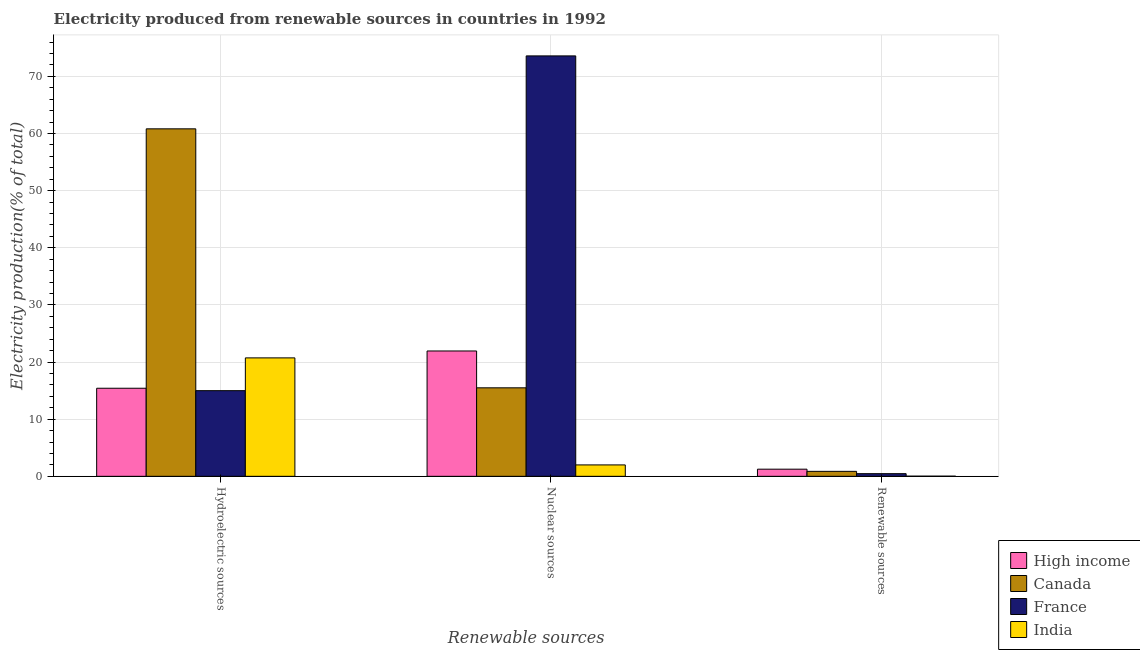How many groups of bars are there?
Make the answer very short. 3. Are the number of bars on each tick of the X-axis equal?
Keep it short and to the point. Yes. What is the label of the 3rd group of bars from the left?
Offer a terse response. Renewable sources. What is the percentage of electricity produced by nuclear sources in High income?
Your response must be concise. 21.93. Across all countries, what is the maximum percentage of electricity produced by renewable sources?
Keep it short and to the point. 1.25. Across all countries, what is the minimum percentage of electricity produced by renewable sources?
Offer a very short reply. 0.03. In which country was the percentage of electricity produced by renewable sources maximum?
Your answer should be compact. High income. What is the total percentage of electricity produced by renewable sources in the graph?
Ensure brevity in your answer.  2.61. What is the difference between the percentage of electricity produced by hydroelectric sources in High income and that in Canada?
Give a very brief answer. -45.4. What is the difference between the percentage of electricity produced by nuclear sources in India and the percentage of electricity produced by renewable sources in Canada?
Keep it short and to the point. 1.12. What is the average percentage of electricity produced by nuclear sources per country?
Provide a succinct answer. 28.25. What is the difference between the percentage of electricity produced by nuclear sources and percentage of electricity produced by hydroelectric sources in Canada?
Provide a short and direct response. -45.32. What is the ratio of the percentage of electricity produced by renewable sources in France to that in High income?
Keep it short and to the point. 0.37. What is the difference between the highest and the second highest percentage of electricity produced by renewable sources?
Keep it short and to the point. 0.38. What is the difference between the highest and the lowest percentage of electricity produced by hydroelectric sources?
Offer a terse response. 45.82. In how many countries, is the percentage of electricity produced by nuclear sources greater than the average percentage of electricity produced by nuclear sources taken over all countries?
Keep it short and to the point. 1. What does the 1st bar from the left in Renewable sources represents?
Offer a very short reply. High income. What does the 3rd bar from the right in Nuclear sources represents?
Your response must be concise. Canada. How many bars are there?
Your answer should be very brief. 12. How many countries are there in the graph?
Offer a terse response. 4. How many legend labels are there?
Provide a succinct answer. 4. What is the title of the graph?
Your answer should be very brief. Electricity produced from renewable sources in countries in 1992. Does "Grenada" appear as one of the legend labels in the graph?
Your response must be concise. No. What is the label or title of the X-axis?
Give a very brief answer. Renewable sources. What is the Electricity production(% of total) in High income in Hydroelectric sources?
Ensure brevity in your answer.  15.41. What is the Electricity production(% of total) in Canada in Hydroelectric sources?
Offer a very short reply. 60.81. What is the Electricity production(% of total) in France in Hydroelectric sources?
Make the answer very short. 14.99. What is the Electricity production(% of total) of India in Hydroelectric sources?
Provide a succinct answer. 20.73. What is the Electricity production(% of total) of High income in Nuclear sources?
Keep it short and to the point. 21.93. What is the Electricity production(% of total) of Canada in Nuclear sources?
Offer a very short reply. 15.49. What is the Electricity production(% of total) of France in Nuclear sources?
Offer a very short reply. 73.57. What is the Electricity production(% of total) of India in Nuclear sources?
Your answer should be very brief. 1.99. What is the Electricity production(% of total) in High income in Renewable sources?
Your answer should be compact. 1.25. What is the Electricity production(% of total) in Canada in Renewable sources?
Keep it short and to the point. 0.87. What is the Electricity production(% of total) of France in Renewable sources?
Offer a terse response. 0.46. What is the Electricity production(% of total) in India in Renewable sources?
Provide a short and direct response. 0.03. Across all Renewable sources, what is the maximum Electricity production(% of total) of High income?
Offer a very short reply. 21.93. Across all Renewable sources, what is the maximum Electricity production(% of total) of Canada?
Keep it short and to the point. 60.81. Across all Renewable sources, what is the maximum Electricity production(% of total) in France?
Your answer should be compact. 73.57. Across all Renewable sources, what is the maximum Electricity production(% of total) of India?
Your response must be concise. 20.73. Across all Renewable sources, what is the minimum Electricity production(% of total) in High income?
Offer a very short reply. 1.25. Across all Renewable sources, what is the minimum Electricity production(% of total) in Canada?
Your answer should be compact. 0.87. Across all Renewable sources, what is the minimum Electricity production(% of total) of France?
Provide a succinct answer. 0.46. Across all Renewable sources, what is the minimum Electricity production(% of total) in India?
Make the answer very short. 0.03. What is the total Electricity production(% of total) in High income in the graph?
Offer a terse response. 38.6. What is the total Electricity production(% of total) in Canada in the graph?
Ensure brevity in your answer.  77.17. What is the total Electricity production(% of total) of France in the graph?
Your response must be concise. 89.03. What is the total Electricity production(% of total) in India in the graph?
Your answer should be compact. 22.75. What is the difference between the Electricity production(% of total) in High income in Hydroelectric sources and that in Nuclear sources?
Offer a very short reply. -6.52. What is the difference between the Electricity production(% of total) in Canada in Hydroelectric sources and that in Nuclear sources?
Provide a succinct answer. 45.32. What is the difference between the Electricity production(% of total) of France in Hydroelectric sources and that in Nuclear sources?
Provide a short and direct response. -58.58. What is the difference between the Electricity production(% of total) in India in Hydroelectric sources and that in Nuclear sources?
Keep it short and to the point. 18.73. What is the difference between the Electricity production(% of total) in High income in Hydroelectric sources and that in Renewable sources?
Provide a short and direct response. 14.16. What is the difference between the Electricity production(% of total) in Canada in Hydroelectric sources and that in Renewable sources?
Offer a very short reply. 59.94. What is the difference between the Electricity production(% of total) of France in Hydroelectric sources and that in Renewable sources?
Provide a succinct answer. 14.53. What is the difference between the Electricity production(% of total) in India in Hydroelectric sources and that in Renewable sources?
Make the answer very short. 20.7. What is the difference between the Electricity production(% of total) of High income in Nuclear sources and that in Renewable sources?
Offer a terse response. 20.68. What is the difference between the Electricity production(% of total) of Canada in Nuclear sources and that in Renewable sources?
Offer a very short reply. 14.62. What is the difference between the Electricity production(% of total) in France in Nuclear sources and that in Renewable sources?
Your response must be concise. 73.11. What is the difference between the Electricity production(% of total) in India in Nuclear sources and that in Renewable sources?
Your answer should be very brief. 1.97. What is the difference between the Electricity production(% of total) in High income in Hydroelectric sources and the Electricity production(% of total) in Canada in Nuclear sources?
Offer a terse response. -0.08. What is the difference between the Electricity production(% of total) of High income in Hydroelectric sources and the Electricity production(% of total) of France in Nuclear sources?
Give a very brief answer. -58.16. What is the difference between the Electricity production(% of total) of High income in Hydroelectric sources and the Electricity production(% of total) of India in Nuclear sources?
Ensure brevity in your answer.  13.42. What is the difference between the Electricity production(% of total) of Canada in Hydroelectric sources and the Electricity production(% of total) of France in Nuclear sources?
Make the answer very short. -12.76. What is the difference between the Electricity production(% of total) of Canada in Hydroelectric sources and the Electricity production(% of total) of India in Nuclear sources?
Offer a very short reply. 58.81. What is the difference between the Electricity production(% of total) of France in Hydroelectric sources and the Electricity production(% of total) of India in Nuclear sources?
Provide a short and direct response. 13. What is the difference between the Electricity production(% of total) of High income in Hydroelectric sources and the Electricity production(% of total) of Canada in Renewable sources?
Your response must be concise. 14.54. What is the difference between the Electricity production(% of total) of High income in Hydroelectric sources and the Electricity production(% of total) of France in Renewable sources?
Keep it short and to the point. 14.95. What is the difference between the Electricity production(% of total) in High income in Hydroelectric sources and the Electricity production(% of total) in India in Renewable sources?
Provide a short and direct response. 15.39. What is the difference between the Electricity production(% of total) of Canada in Hydroelectric sources and the Electricity production(% of total) of France in Renewable sources?
Provide a short and direct response. 60.35. What is the difference between the Electricity production(% of total) in Canada in Hydroelectric sources and the Electricity production(% of total) in India in Renewable sources?
Ensure brevity in your answer.  60.78. What is the difference between the Electricity production(% of total) in France in Hydroelectric sources and the Electricity production(% of total) in India in Renewable sources?
Make the answer very short. 14.96. What is the difference between the Electricity production(% of total) in High income in Nuclear sources and the Electricity production(% of total) in Canada in Renewable sources?
Your answer should be very brief. 21.06. What is the difference between the Electricity production(% of total) of High income in Nuclear sources and the Electricity production(% of total) of France in Renewable sources?
Keep it short and to the point. 21.47. What is the difference between the Electricity production(% of total) in High income in Nuclear sources and the Electricity production(% of total) in India in Renewable sources?
Offer a very short reply. 21.91. What is the difference between the Electricity production(% of total) of Canada in Nuclear sources and the Electricity production(% of total) of France in Renewable sources?
Give a very brief answer. 15.02. What is the difference between the Electricity production(% of total) in Canada in Nuclear sources and the Electricity production(% of total) in India in Renewable sources?
Your response must be concise. 15.46. What is the difference between the Electricity production(% of total) in France in Nuclear sources and the Electricity production(% of total) in India in Renewable sources?
Offer a terse response. 73.55. What is the average Electricity production(% of total) in High income per Renewable sources?
Give a very brief answer. 12.87. What is the average Electricity production(% of total) in Canada per Renewable sources?
Provide a succinct answer. 25.72. What is the average Electricity production(% of total) in France per Renewable sources?
Offer a terse response. 29.68. What is the average Electricity production(% of total) in India per Renewable sources?
Give a very brief answer. 7.58. What is the difference between the Electricity production(% of total) of High income and Electricity production(% of total) of Canada in Hydroelectric sources?
Keep it short and to the point. -45.4. What is the difference between the Electricity production(% of total) of High income and Electricity production(% of total) of France in Hydroelectric sources?
Your response must be concise. 0.42. What is the difference between the Electricity production(% of total) in High income and Electricity production(% of total) in India in Hydroelectric sources?
Offer a terse response. -5.31. What is the difference between the Electricity production(% of total) in Canada and Electricity production(% of total) in France in Hydroelectric sources?
Make the answer very short. 45.82. What is the difference between the Electricity production(% of total) of Canada and Electricity production(% of total) of India in Hydroelectric sources?
Provide a succinct answer. 40.08. What is the difference between the Electricity production(% of total) in France and Electricity production(% of total) in India in Hydroelectric sources?
Make the answer very short. -5.74. What is the difference between the Electricity production(% of total) of High income and Electricity production(% of total) of Canada in Nuclear sources?
Provide a short and direct response. 6.45. What is the difference between the Electricity production(% of total) in High income and Electricity production(% of total) in France in Nuclear sources?
Your answer should be very brief. -51.64. What is the difference between the Electricity production(% of total) of High income and Electricity production(% of total) of India in Nuclear sources?
Make the answer very short. 19.94. What is the difference between the Electricity production(% of total) of Canada and Electricity production(% of total) of France in Nuclear sources?
Your answer should be very brief. -58.09. What is the difference between the Electricity production(% of total) in Canada and Electricity production(% of total) in India in Nuclear sources?
Ensure brevity in your answer.  13.49. What is the difference between the Electricity production(% of total) in France and Electricity production(% of total) in India in Nuclear sources?
Provide a short and direct response. 71.58. What is the difference between the Electricity production(% of total) in High income and Electricity production(% of total) in Canada in Renewable sources?
Provide a short and direct response. 0.38. What is the difference between the Electricity production(% of total) of High income and Electricity production(% of total) of France in Renewable sources?
Your answer should be very brief. 0.78. What is the difference between the Electricity production(% of total) of High income and Electricity production(% of total) of India in Renewable sources?
Offer a terse response. 1.22. What is the difference between the Electricity production(% of total) of Canada and Electricity production(% of total) of France in Renewable sources?
Keep it short and to the point. 0.41. What is the difference between the Electricity production(% of total) of Canada and Electricity production(% of total) of India in Renewable sources?
Keep it short and to the point. 0.84. What is the difference between the Electricity production(% of total) in France and Electricity production(% of total) in India in Renewable sources?
Provide a short and direct response. 0.44. What is the ratio of the Electricity production(% of total) of High income in Hydroelectric sources to that in Nuclear sources?
Offer a terse response. 0.7. What is the ratio of the Electricity production(% of total) in Canada in Hydroelectric sources to that in Nuclear sources?
Offer a terse response. 3.93. What is the ratio of the Electricity production(% of total) in France in Hydroelectric sources to that in Nuclear sources?
Your answer should be very brief. 0.2. What is the ratio of the Electricity production(% of total) in India in Hydroelectric sources to that in Nuclear sources?
Provide a succinct answer. 10.39. What is the ratio of the Electricity production(% of total) of High income in Hydroelectric sources to that in Renewable sources?
Offer a terse response. 12.34. What is the ratio of the Electricity production(% of total) of Canada in Hydroelectric sources to that in Renewable sources?
Your answer should be very brief. 69.9. What is the ratio of the Electricity production(% of total) of France in Hydroelectric sources to that in Renewable sources?
Your response must be concise. 32.31. What is the ratio of the Electricity production(% of total) of India in Hydroelectric sources to that in Renewable sources?
Make the answer very short. 794.16. What is the ratio of the Electricity production(% of total) in High income in Nuclear sources to that in Renewable sources?
Your answer should be compact. 17.57. What is the ratio of the Electricity production(% of total) of Canada in Nuclear sources to that in Renewable sources?
Your answer should be compact. 17.8. What is the ratio of the Electricity production(% of total) in France in Nuclear sources to that in Renewable sources?
Give a very brief answer. 158.6. What is the ratio of the Electricity production(% of total) in India in Nuclear sources to that in Renewable sources?
Give a very brief answer. 76.43. What is the difference between the highest and the second highest Electricity production(% of total) of High income?
Your response must be concise. 6.52. What is the difference between the highest and the second highest Electricity production(% of total) in Canada?
Your answer should be very brief. 45.32. What is the difference between the highest and the second highest Electricity production(% of total) of France?
Give a very brief answer. 58.58. What is the difference between the highest and the second highest Electricity production(% of total) in India?
Keep it short and to the point. 18.73. What is the difference between the highest and the lowest Electricity production(% of total) in High income?
Your answer should be very brief. 20.68. What is the difference between the highest and the lowest Electricity production(% of total) of Canada?
Your answer should be compact. 59.94. What is the difference between the highest and the lowest Electricity production(% of total) of France?
Your answer should be compact. 73.11. What is the difference between the highest and the lowest Electricity production(% of total) of India?
Keep it short and to the point. 20.7. 